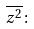Convert formula to latex. <formula><loc_0><loc_0><loc_500><loc_500>\overline { z ^ { 2 } } \colon</formula> 